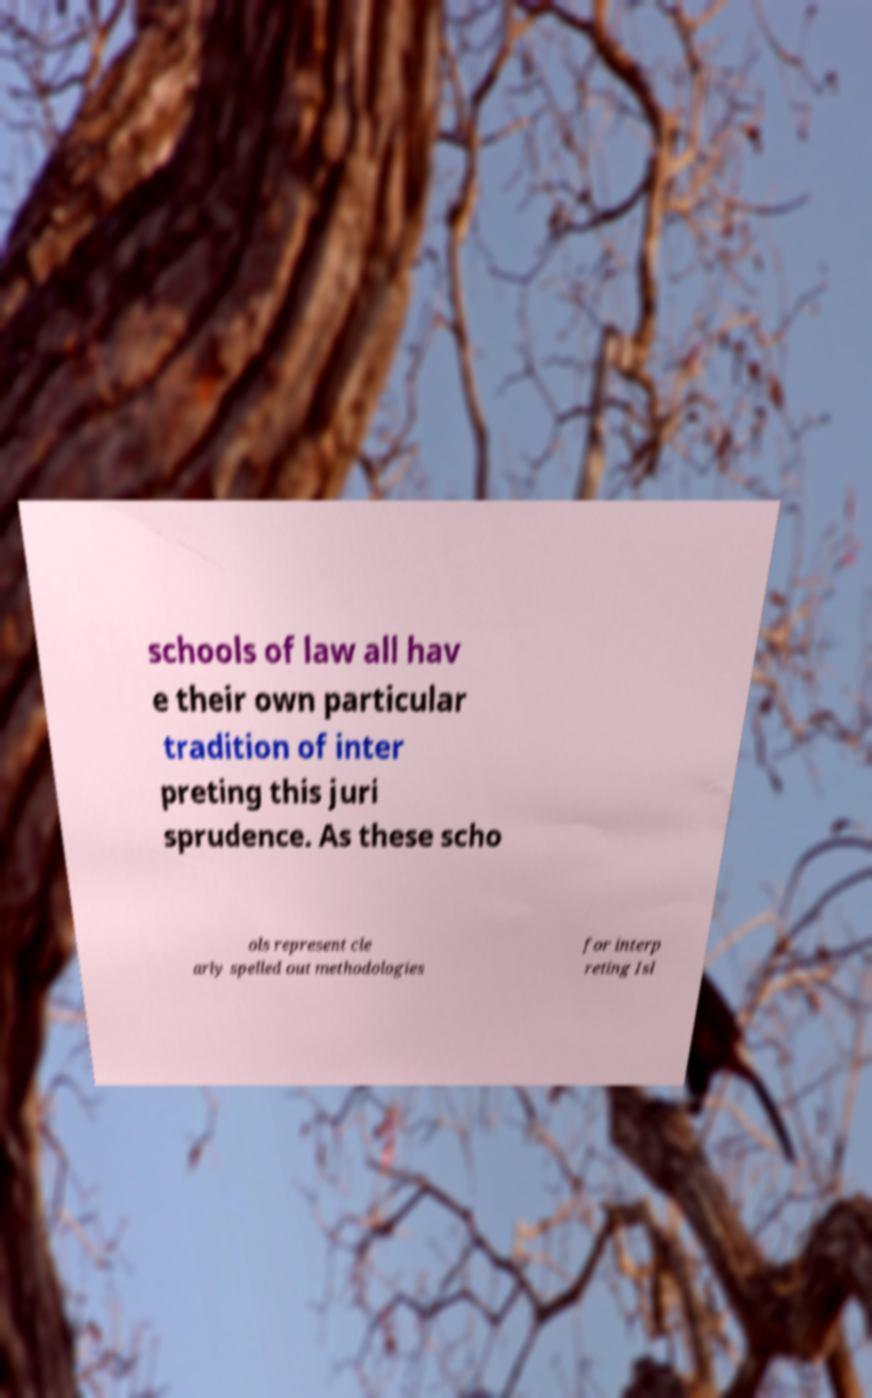Can you accurately transcribe the text from the provided image for me? schools of law all hav e their own particular tradition of inter preting this juri sprudence. As these scho ols represent cle arly spelled out methodologies for interp reting Isl 